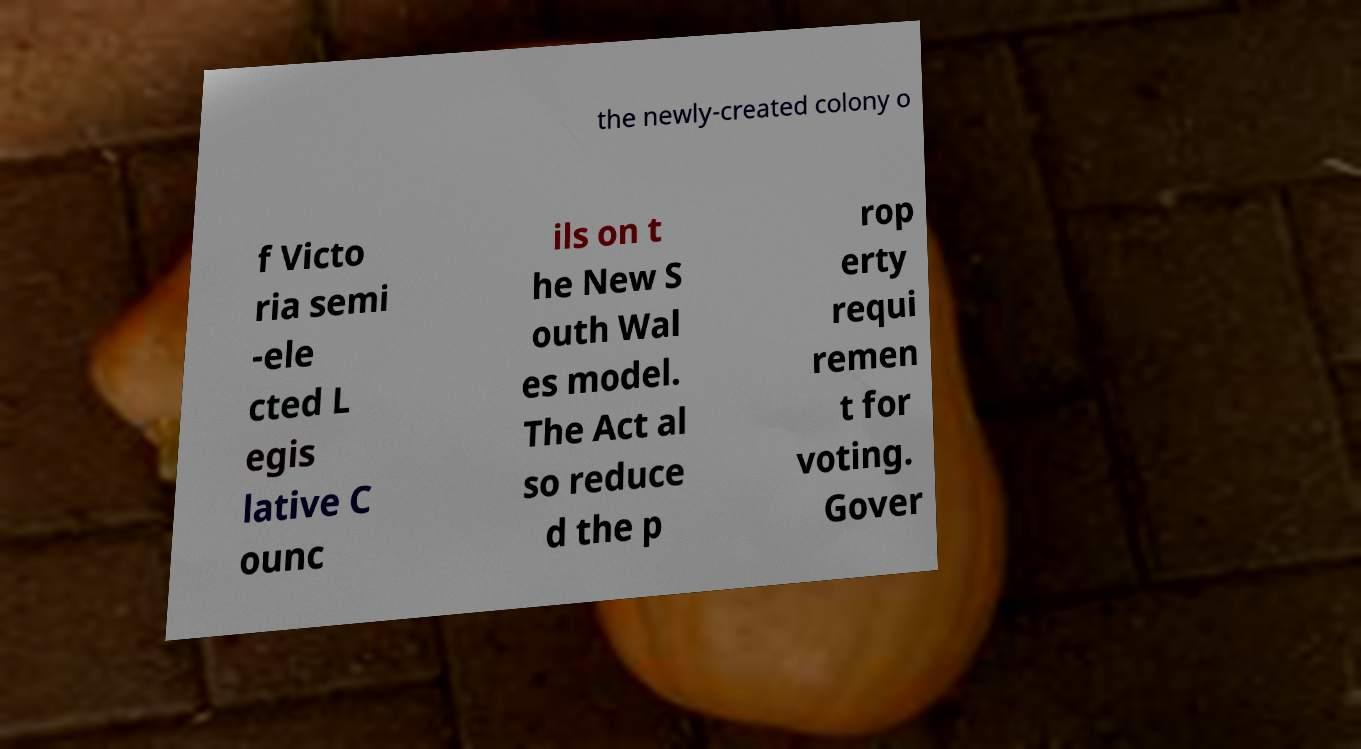Could you extract and type out the text from this image? the newly-created colony o f Victo ria semi -ele cted L egis lative C ounc ils on t he New S outh Wal es model. The Act al so reduce d the p rop erty requi remen t for voting. Gover 